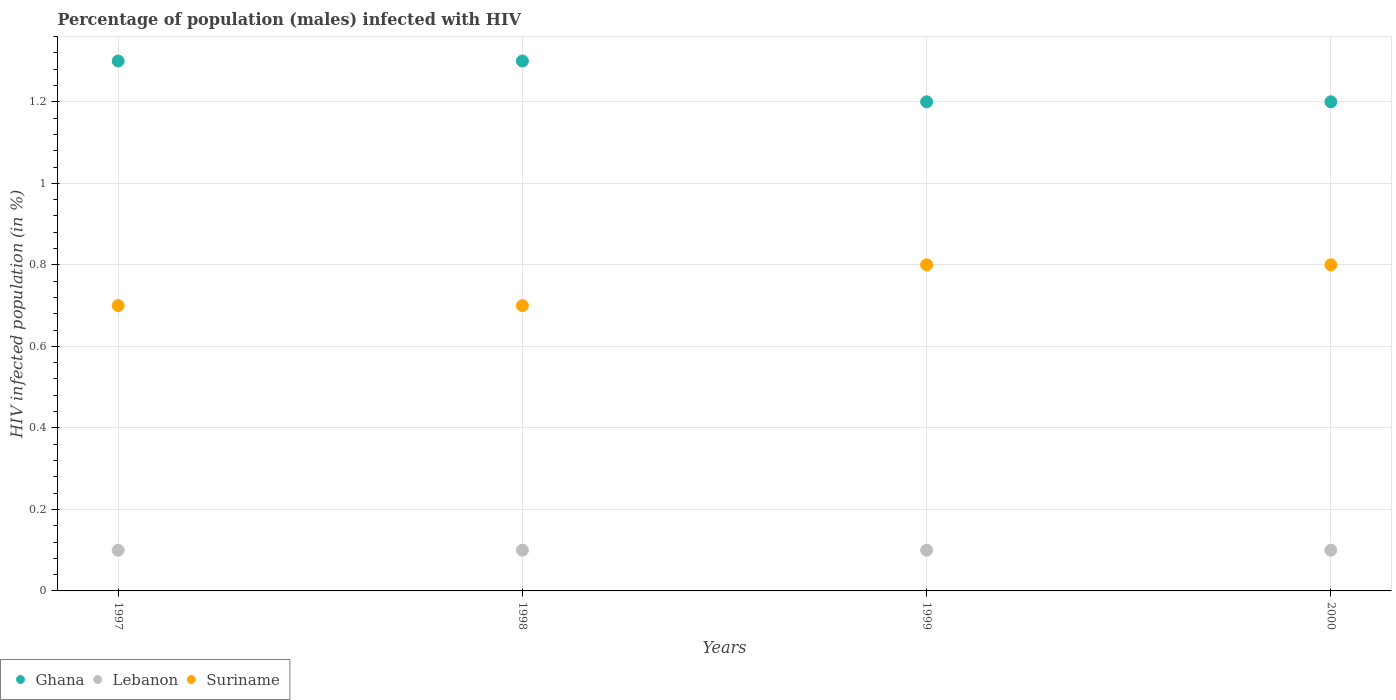Is the number of dotlines equal to the number of legend labels?
Your response must be concise. Yes. Across all years, what is the maximum percentage of HIV infected male population in Ghana?
Provide a succinct answer. 1.3. Across all years, what is the minimum percentage of HIV infected male population in Suriname?
Provide a short and direct response. 0.7. In which year was the percentage of HIV infected male population in Lebanon maximum?
Offer a terse response. 1997. In which year was the percentage of HIV infected male population in Ghana minimum?
Your answer should be compact. 1999. What is the difference between the percentage of HIV infected male population in Lebanon in 1998 and that in 2000?
Ensure brevity in your answer.  0. What is the difference between the percentage of HIV infected male population in Lebanon in 1998 and the percentage of HIV infected male population in Suriname in 1999?
Your response must be concise. -0.7. What is the average percentage of HIV infected male population in Lebanon per year?
Give a very brief answer. 0.1. In the year 1997, what is the difference between the percentage of HIV infected male population in Suriname and percentage of HIV infected male population in Ghana?
Ensure brevity in your answer.  -0.6. In how many years, is the percentage of HIV infected male population in Ghana greater than 1 %?
Offer a terse response. 4. What is the ratio of the percentage of HIV infected male population in Lebanon in 1998 to that in 1999?
Your response must be concise. 1. Is the percentage of HIV infected male population in Suriname in 1997 less than that in 2000?
Your response must be concise. Yes. What is the difference between the highest and the second highest percentage of HIV infected male population in Ghana?
Provide a short and direct response. 0. What is the difference between the highest and the lowest percentage of HIV infected male population in Lebanon?
Offer a terse response. 0. Is it the case that in every year, the sum of the percentage of HIV infected male population in Lebanon and percentage of HIV infected male population in Ghana  is greater than the percentage of HIV infected male population in Suriname?
Provide a succinct answer. Yes. Does the percentage of HIV infected male population in Suriname monotonically increase over the years?
Your response must be concise. No. How many dotlines are there?
Ensure brevity in your answer.  3. What is the difference between two consecutive major ticks on the Y-axis?
Make the answer very short. 0.2. Are the values on the major ticks of Y-axis written in scientific E-notation?
Make the answer very short. No. What is the title of the graph?
Ensure brevity in your answer.  Percentage of population (males) infected with HIV. What is the label or title of the Y-axis?
Make the answer very short. HIV infected population (in %). What is the HIV infected population (in %) in Ghana in 1997?
Give a very brief answer. 1.3. What is the HIV infected population (in %) of Lebanon in 1997?
Your answer should be very brief. 0.1. What is the HIV infected population (in %) in Suriname in 1997?
Provide a succinct answer. 0.7. What is the HIV infected population (in %) in Lebanon in 1998?
Your answer should be very brief. 0.1. What is the HIV infected population (in %) in Lebanon in 1999?
Your answer should be very brief. 0.1. Across all years, what is the maximum HIV infected population (in %) in Ghana?
Ensure brevity in your answer.  1.3. Across all years, what is the maximum HIV infected population (in %) in Lebanon?
Your answer should be compact. 0.1. Across all years, what is the maximum HIV infected population (in %) of Suriname?
Ensure brevity in your answer.  0.8. Across all years, what is the minimum HIV infected population (in %) in Ghana?
Ensure brevity in your answer.  1.2. Across all years, what is the minimum HIV infected population (in %) in Suriname?
Make the answer very short. 0.7. What is the total HIV infected population (in %) of Ghana in the graph?
Keep it short and to the point. 5. What is the total HIV infected population (in %) in Suriname in the graph?
Ensure brevity in your answer.  3. What is the difference between the HIV infected population (in %) of Lebanon in 1997 and that in 1998?
Make the answer very short. 0. What is the difference between the HIV infected population (in %) of Suriname in 1997 and that in 1998?
Provide a succinct answer. 0. What is the difference between the HIV infected population (in %) of Suriname in 1997 and that in 1999?
Provide a short and direct response. -0.1. What is the difference between the HIV infected population (in %) of Ghana in 1997 and that in 2000?
Provide a short and direct response. 0.1. What is the difference between the HIV infected population (in %) of Ghana in 1998 and that in 1999?
Provide a succinct answer. 0.1. What is the difference between the HIV infected population (in %) of Ghana in 1998 and that in 2000?
Your answer should be compact. 0.1. What is the difference between the HIV infected population (in %) of Lebanon in 1998 and that in 2000?
Offer a very short reply. 0. What is the difference between the HIV infected population (in %) of Lebanon in 1999 and that in 2000?
Give a very brief answer. 0. What is the difference between the HIV infected population (in %) in Ghana in 1997 and the HIV infected population (in %) in Lebanon in 1998?
Ensure brevity in your answer.  1.2. What is the difference between the HIV infected population (in %) of Lebanon in 1997 and the HIV infected population (in %) of Suriname in 1998?
Offer a very short reply. -0.6. What is the difference between the HIV infected population (in %) of Ghana in 1997 and the HIV infected population (in %) of Lebanon in 1999?
Ensure brevity in your answer.  1.2. What is the difference between the HIV infected population (in %) in Ghana in 1997 and the HIV infected population (in %) in Suriname in 1999?
Offer a very short reply. 0.5. What is the difference between the HIV infected population (in %) of Ghana in 1997 and the HIV infected population (in %) of Lebanon in 2000?
Offer a terse response. 1.2. What is the difference between the HIV infected population (in %) in Ghana in 1997 and the HIV infected population (in %) in Suriname in 2000?
Your answer should be compact. 0.5. What is the difference between the HIV infected population (in %) of Ghana in 1998 and the HIV infected population (in %) of Lebanon in 1999?
Provide a succinct answer. 1.2. What is the difference between the HIV infected population (in %) of Ghana in 1998 and the HIV infected population (in %) of Lebanon in 2000?
Make the answer very short. 1.2. What is the difference between the HIV infected population (in %) of Ghana in 1999 and the HIV infected population (in %) of Lebanon in 2000?
Offer a terse response. 1.1. What is the average HIV infected population (in %) of Suriname per year?
Make the answer very short. 0.75. In the year 1997, what is the difference between the HIV infected population (in %) of Ghana and HIV infected population (in %) of Suriname?
Give a very brief answer. 0.6. In the year 1998, what is the difference between the HIV infected population (in %) in Ghana and HIV infected population (in %) in Suriname?
Ensure brevity in your answer.  0.6. In the year 1998, what is the difference between the HIV infected population (in %) of Lebanon and HIV infected population (in %) of Suriname?
Your response must be concise. -0.6. In the year 1999, what is the difference between the HIV infected population (in %) of Ghana and HIV infected population (in %) of Suriname?
Make the answer very short. 0.4. In the year 2000, what is the difference between the HIV infected population (in %) in Ghana and HIV infected population (in %) in Lebanon?
Your response must be concise. 1.1. In the year 2000, what is the difference between the HIV infected population (in %) of Ghana and HIV infected population (in %) of Suriname?
Offer a terse response. 0.4. What is the ratio of the HIV infected population (in %) of Ghana in 1997 to that in 1998?
Your answer should be very brief. 1. What is the ratio of the HIV infected population (in %) in Lebanon in 1997 to that in 1998?
Your response must be concise. 1. What is the ratio of the HIV infected population (in %) of Suriname in 1997 to that in 1998?
Your answer should be compact. 1. What is the ratio of the HIV infected population (in %) of Lebanon in 1997 to that in 1999?
Keep it short and to the point. 1. What is the ratio of the HIV infected population (in %) in Suriname in 1997 to that in 1999?
Provide a succinct answer. 0.88. What is the ratio of the HIV infected population (in %) of Ghana in 1998 to that in 1999?
Make the answer very short. 1.08. What is the ratio of the HIV infected population (in %) of Lebanon in 1998 to that in 2000?
Provide a succinct answer. 1. What is the ratio of the HIV infected population (in %) of Suriname in 1998 to that in 2000?
Your answer should be very brief. 0.88. What is the ratio of the HIV infected population (in %) in Lebanon in 1999 to that in 2000?
Your answer should be compact. 1. What is the difference between the highest and the second highest HIV infected population (in %) in Ghana?
Your answer should be very brief. 0. What is the difference between the highest and the second highest HIV infected population (in %) in Lebanon?
Provide a short and direct response. 0. What is the difference between the highest and the second highest HIV infected population (in %) of Suriname?
Offer a terse response. 0. What is the difference between the highest and the lowest HIV infected population (in %) in Suriname?
Offer a terse response. 0.1. 